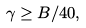<formula> <loc_0><loc_0><loc_500><loc_500>\gamma \geq B / 4 0 ,</formula> 